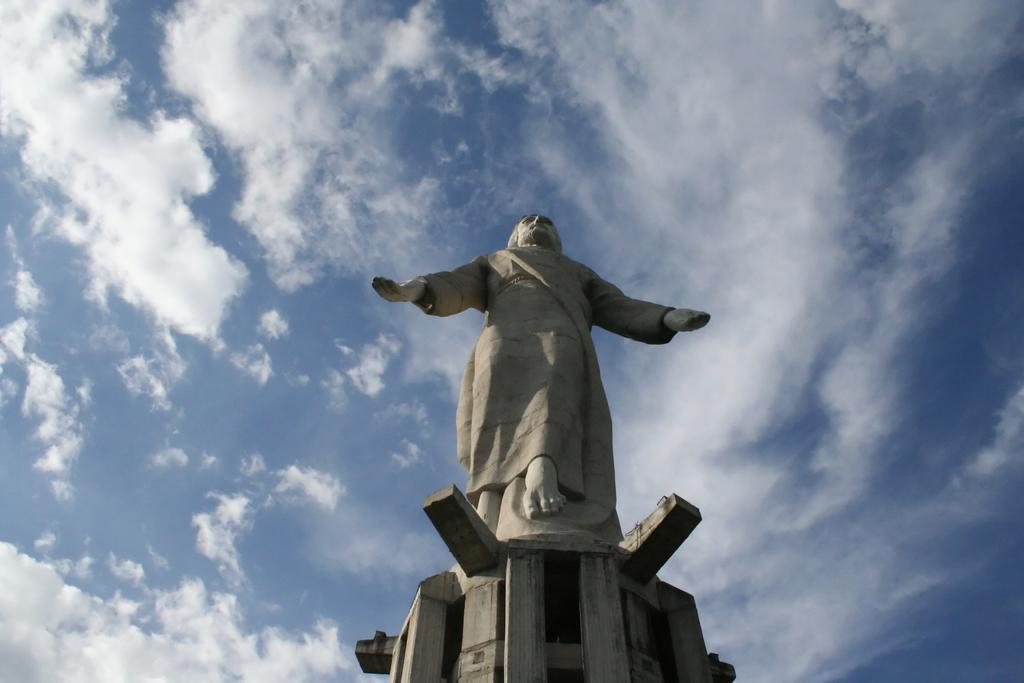What is the main subject of the image? The main subject of the image is a statue of a person. What is the statue placed on? The statue is on an object. What can be seen in the sky in the image? There are clouds visible in the sky in the image. What type of salt can be seen on the coast in the image? There is no salt or coast present in the image; it features a statue of a person on an object with clouds visible in the sky. 